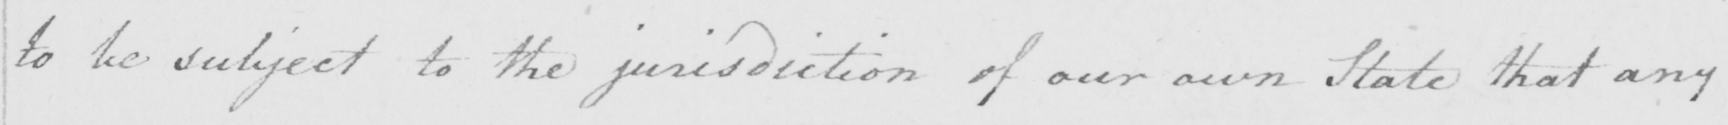Transcribe the text shown in this historical manuscript line. to be subject to the jurisdiction of our own State that any 